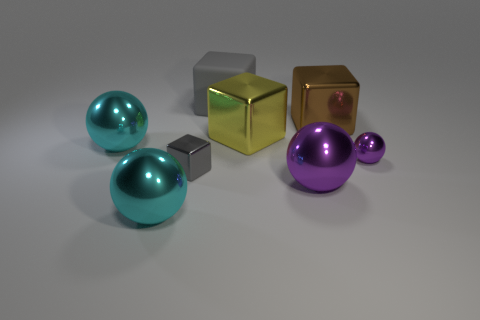Subtract all big purple shiny balls. How many balls are left? 3 Subtract all yellow cubes. How many cubes are left? 3 Subtract all red cubes. Subtract all yellow cylinders. How many cubes are left? 4 Add 1 green metallic cubes. How many objects exist? 9 Add 8 large gray cubes. How many large gray cubes are left? 9 Add 6 large yellow metal cylinders. How many large yellow metal cylinders exist? 6 Subtract 1 brown cubes. How many objects are left? 7 Subtract all large metal objects. Subtract all gray shiny blocks. How many objects are left? 2 